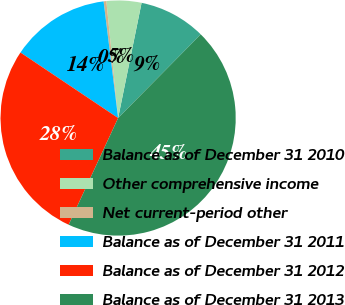Convert chart. <chart><loc_0><loc_0><loc_500><loc_500><pie_chart><fcel>Balance as of December 31 2010<fcel>Other comprehensive income<fcel>Net current-period other<fcel>Balance as of December 31 2011<fcel>Balance as of December 31 2012<fcel>Balance as of December 31 2013<nl><fcel>9.2%<fcel>4.79%<fcel>0.38%<fcel>13.62%<fcel>27.5%<fcel>44.51%<nl></chart> 